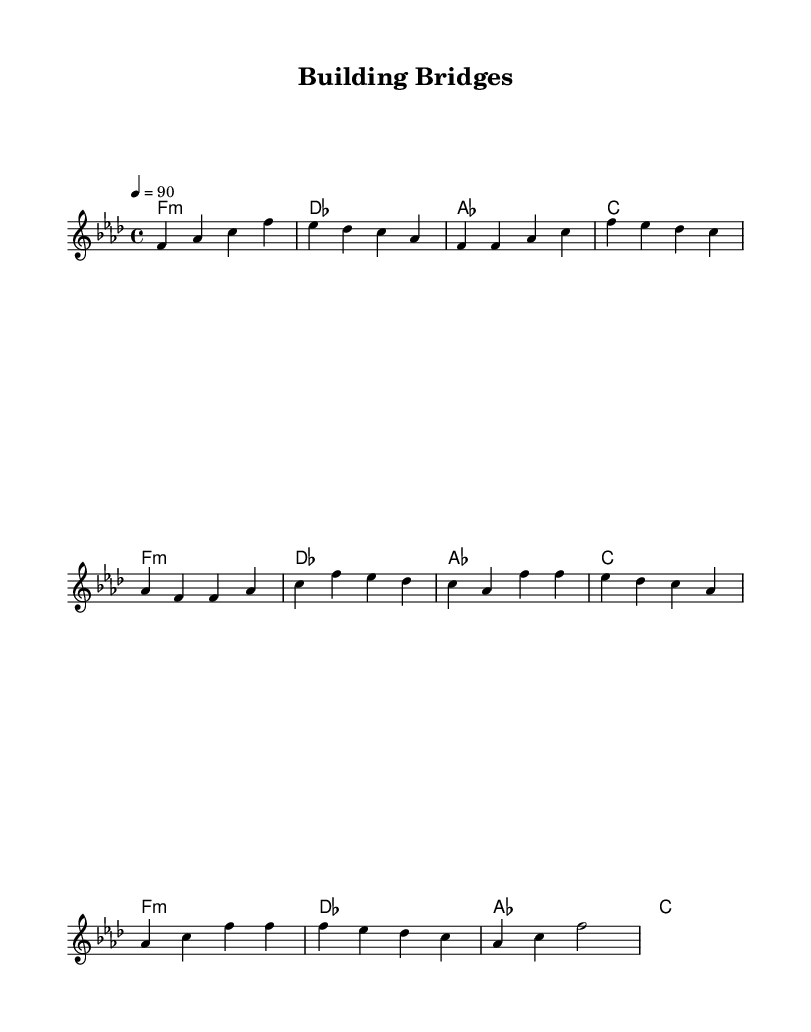What is the key signature of this music? The key signature is indicated at the beginning of the staff. It shows a flat sign on the B line, confirming that this piece is in F minor, which has 4 flats (B♭, E♭, A♭, and D♭).
Answer: F minor What is the time signature of this music? The time signature appears right after the key signature at the beginning of the music. In this case, it is indicated as 4/4, meaning there are four beats in each measure and the quarter note gets one beat.
Answer: 4/4 What is the tempo marking in this piece? The tempo marking is listed above the staff and shows a metronome marking of 90 beats per minute, indicating how fast the music should be played.
Answer: 90 How many measures are in the verse section? By counting the measures within the "Verse" section of the music, which is provided in the melody part, there are a total of 8 measures in this section.
Answer: 8 How many times is the chord F minor played? Looking at the "harmonies" section, the F minor chord is played once in each set of measures, totaling 4 times when considering the complete repetition across the verses.
Answer: 4 What is the overall structure of this rap piece? The structure can be derived by analyzing the major sections in the music: an intro, a verse repeated twice, and a chorus repeated twice, typical for rap music's emphasis on repetitive structures for emphasis.
Answer: Intro, Verse, Chorus 